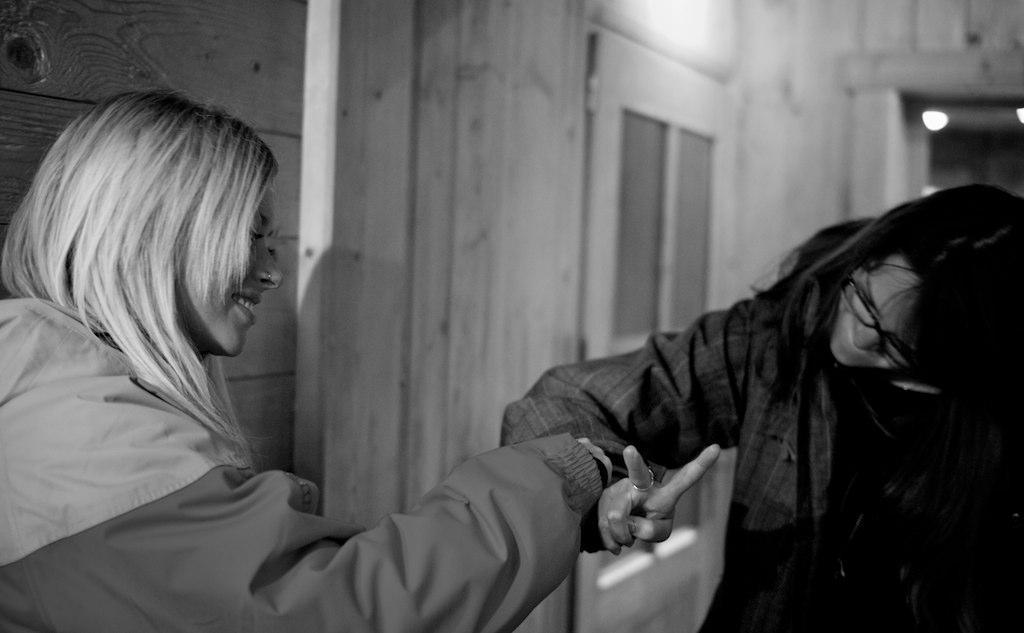What is the color scheme of the image? The image is black and white. How many people are in the image? There are two people in the image. What are the people wearing? Both people are wearing coats. Can you describe one of the people's accessories? One person is wearing glasses. What can be seen in the background of the image? There are lights, a door, and a wall in the background of the image. Can you tell me how many monkeys are sitting on the fan in the image? There are no monkeys or fans present in the image. What type of string is being used by the person in the image? There is no string visible in the image. 